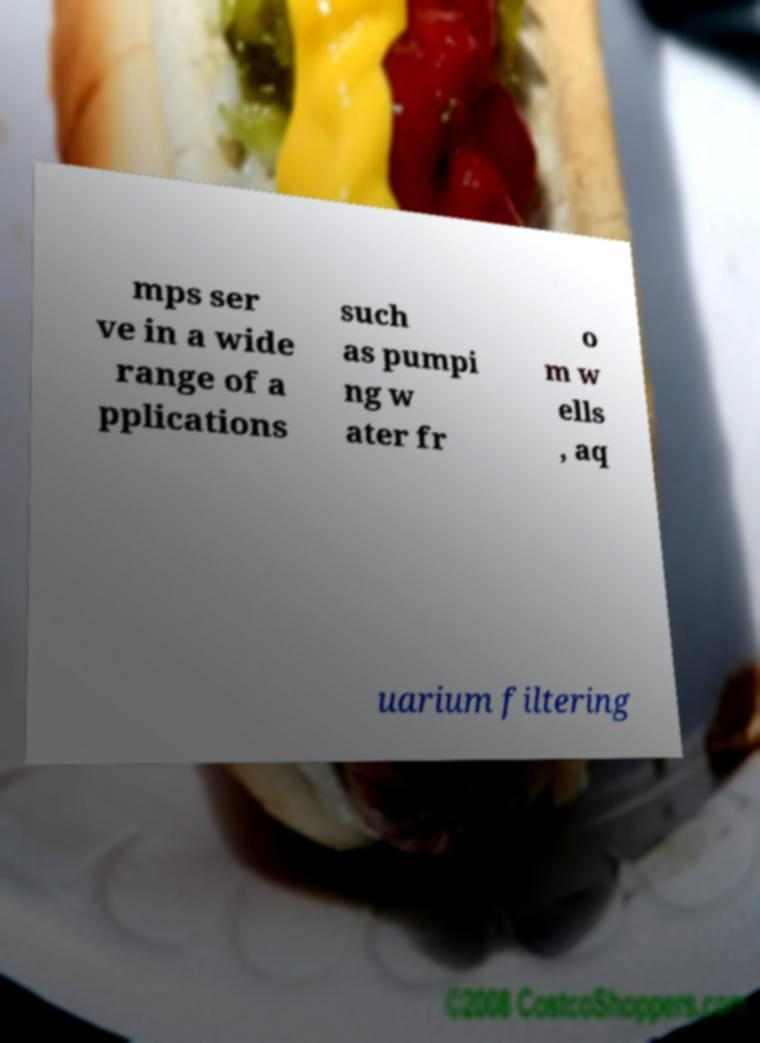There's text embedded in this image that I need extracted. Can you transcribe it verbatim? mps ser ve in a wide range of a pplications such as pumpi ng w ater fr o m w ells , aq uarium filtering 